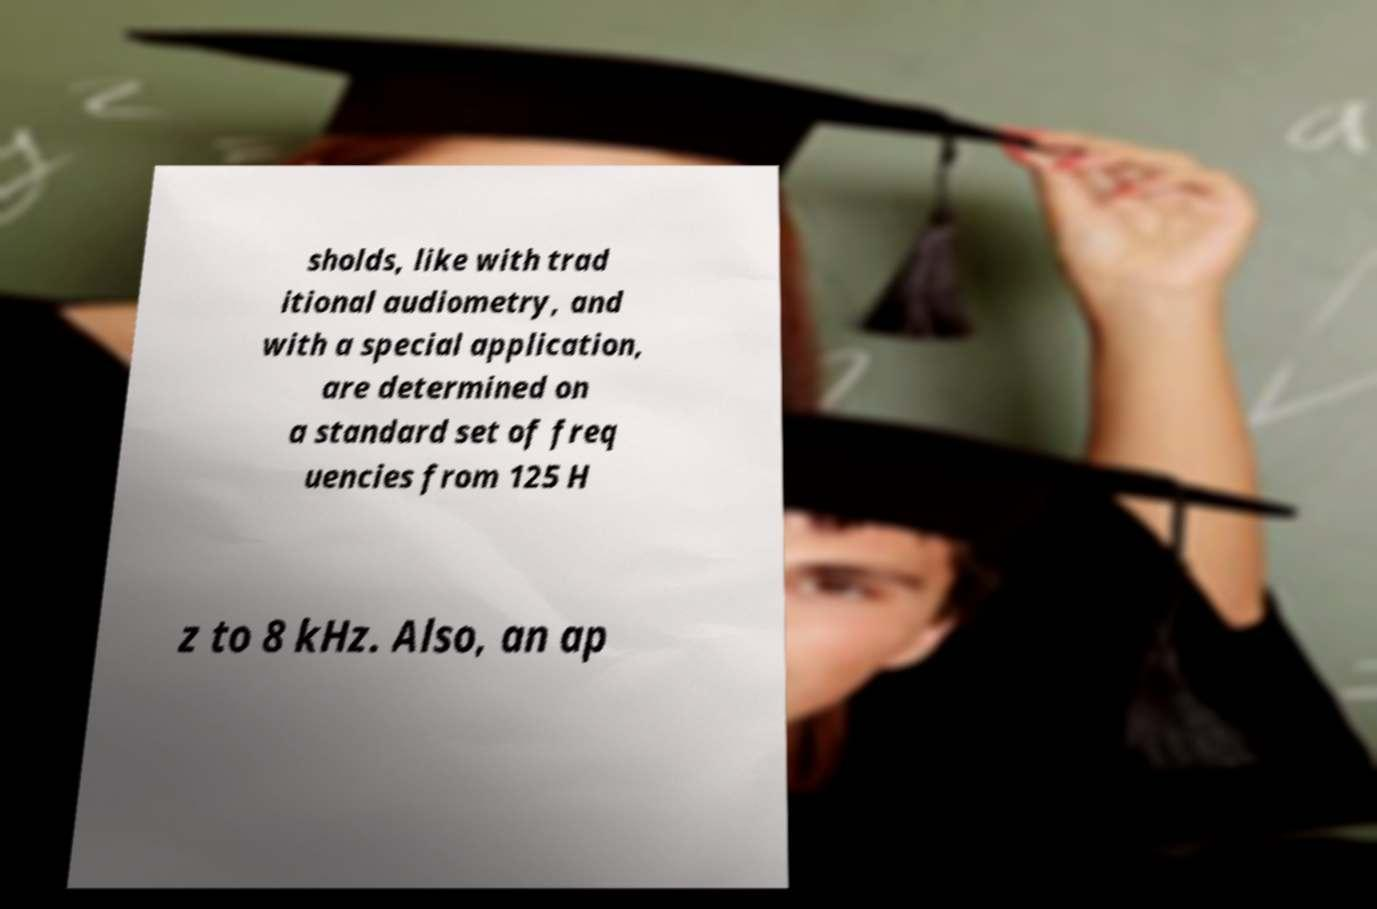Can you accurately transcribe the text from the provided image for me? sholds, like with trad itional audiometry, and with a special application, are determined on a standard set of freq uencies from 125 H z to 8 kHz. Also, an ap 